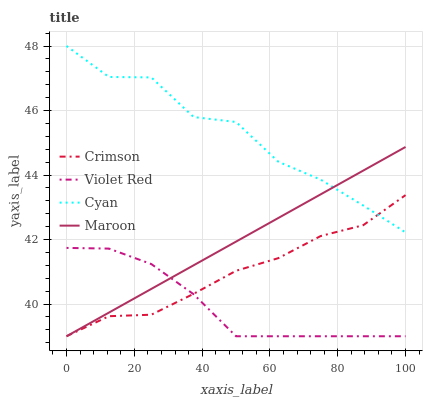Does Violet Red have the minimum area under the curve?
Answer yes or no. Yes. Does Cyan have the maximum area under the curve?
Answer yes or no. Yes. Does Cyan have the minimum area under the curve?
Answer yes or no. No. Does Violet Red have the maximum area under the curve?
Answer yes or no. No. Is Maroon the smoothest?
Answer yes or no. Yes. Is Cyan the roughest?
Answer yes or no. Yes. Is Violet Red the smoothest?
Answer yes or no. No. Is Violet Red the roughest?
Answer yes or no. No. Does Crimson have the lowest value?
Answer yes or no. Yes. Does Cyan have the lowest value?
Answer yes or no. No. Does Cyan have the highest value?
Answer yes or no. Yes. Does Violet Red have the highest value?
Answer yes or no. No. Is Violet Red less than Cyan?
Answer yes or no. Yes. Is Cyan greater than Violet Red?
Answer yes or no. Yes. Does Violet Red intersect Maroon?
Answer yes or no. Yes. Is Violet Red less than Maroon?
Answer yes or no. No. Is Violet Red greater than Maroon?
Answer yes or no. No. Does Violet Red intersect Cyan?
Answer yes or no. No. 